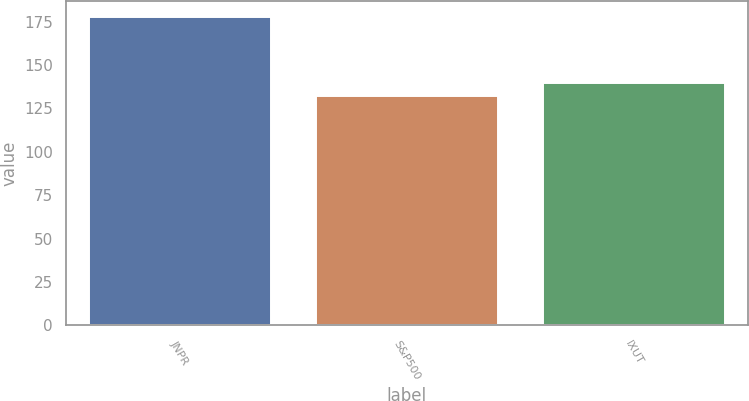<chart> <loc_0><loc_0><loc_500><loc_500><bar_chart><fcel>JNPR<fcel>S&P500<fcel>IXUT<nl><fcel>177.73<fcel>132.06<fcel>139.77<nl></chart> 